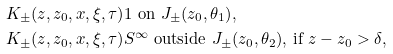Convert formula to latex. <formula><loc_0><loc_0><loc_500><loc_500>K _ { \pm } ( z , z _ { 0 } , x , \xi , \tau ) & 1 \text { on $J_{\pm}(z_{0},\theta_{1})$} , \\ K _ { \pm } ( z , z _ { 0 } , x , \xi , \tau ) & S ^ { \infty } \text { outside $J_{\pm}(z_{0},\theta_{2})$,     if $z-z_{0} > \delta$} ,</formula> 